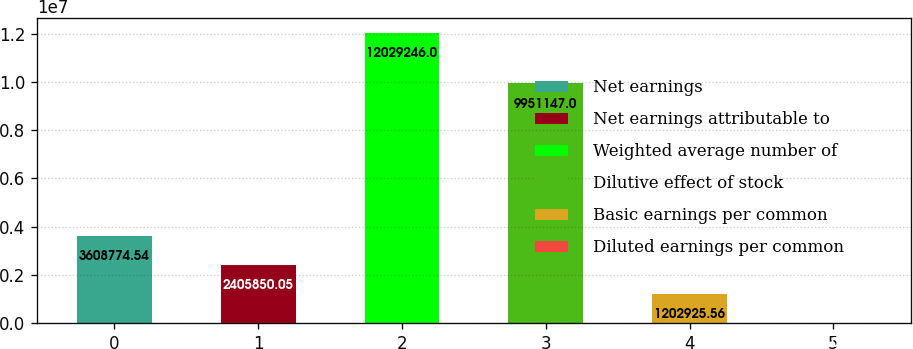<chart> <loc_0><loc_0><loc_500><loc_500><bar_chart><fcel>Net earnings<fcel>Net earnings attributable to<fcel>Weighted average number of<fcel>Dilutive effect of stock<fcel>Basic earnings per common<fcel>Diluted earnings per common<nl><fcel>3.60877e+06<fcel>2.40585e+06<fcel>1.20292e+07<fcel>9.95115e+06<fcel>1.20293e+06<fcel>1.07<nl></chart> 